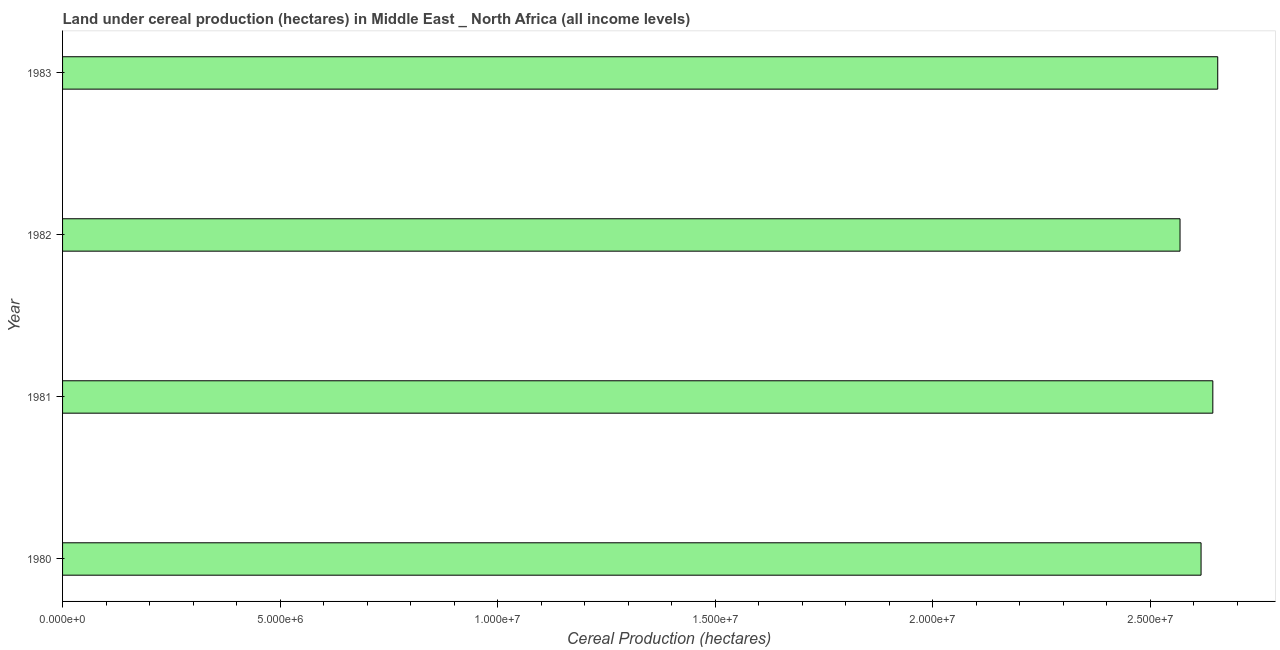Does the graph contain any zero values?
Your response must be concise. No. Does the graph contain grids?
Your response must be concise. No. What is the title of the graph?
Offer a very short reply. Land under cereal production (hectares) in Middle East _ North Africa (all income levels). What is the label or title of the X-axis?
Give a very brief answer. Cereal Production (hectares). What is the label or title of the Y-axis?
Ensure brevity in your answer.  Year. What is the land under cereal production in 1980?
Ensure brevity in your answer.  2.62e+07. Across all years, what is the maximum land under cereal production?
Provide a short and direct response. 2.66e+07. Across all years, what is the minimum land under cereal production?
Keep it short and to the point. 2.57e+07. In which year was the land under cereal production maximum?
Provide a short and direct response. 1983. In which year was the land under cereal production minimum?
Make the answer very short. 1982. What is the sum of the land under cereal production?
Offer a terse response. 1.05e+08. What is the difference between the land under cereal production in 1980 and 1983?
Your response must be concise. -3.83e+05. What is the average land under cereal production per year?
Make the answer very short. 2.62e+07. What is the median land under cereal production?
Your response must be concise. 2.63e+07. Is the land under cereal production in 1980 less than that in 1982?
Keep it short and to the point. No. What is the difference between the highest and the second highest land under cereal production?
Make the answer very short. 1.13e+05. Is the sum of the land under cereal production in 1981 and 1983 greater than the maximum land under cereal production across all years?
Ensure brevity in your answer.  Yes. What is the difference between the highest and the lowest land under cereal production?
Your answer should be compact. 8.67e+05. In how many years, is the land under cereal production greater than the average land under cereal production taken over all years?
Make the answer very short. 2. How many years are there in the graph?
Your answer should be compact. 4. What is the difference between two consecutive major ticks on the X-axis?
Your answer should be compact. 5.00e+06. What is the Cereal Production (hectares) in 1980?
Offer a terse response. 2.62e+07. What is the Cereal Production (hectares) of 1981?
Make the answer very short. 2.64e+07. What is the Cereal Production (hectares) in 1982?
Make the answer very short. 2.57e+07. What is the Cereal Production (hectares) in 1983?
Ensure brevity in your answer.  2.66e+07. What is the difference between the Cereal Production (hectares) in 1980 and 1981?
Provide a short and direct response. -2.70e+05. What is the difference between the Cereal Production (hectares) in 1980 and 1982?
Make the answer very short. 4.83e+05. What is the difference between the Cereal Production (hectares) in 1980 and 1983?
Your response must be concise. -3.83e+05. What is the difference between the Cereal Production (hectares) in 1981 and 1982?
Your answer should be very brief. 7.54e+05. What is the difference between the Cereal Production (hectares) in 1981 and 1983?
Give a very brief answer. -1.13e+05. What is the difference between the Cereal Production (hectares) in 1982 and 1983?
Offer a terse response. -8.67e+05. What is the ratio of the Cereal Production (hectares) in 1980 to that in 1981?
Make the answer very short. 0.99. What is the ratio of the Cereal Production (hectares) in 1980 to that in 1983?
Your answer should be very brief. 0.99. What is the ratio of the Cereal Production (hectares) in 1981 to that in 1982?
Provide a succinct answer. 1.03. What is the ratio of the Cereal Production (hectares) in 1981 to that in 1983?
Provide a succinct answer. 1. 